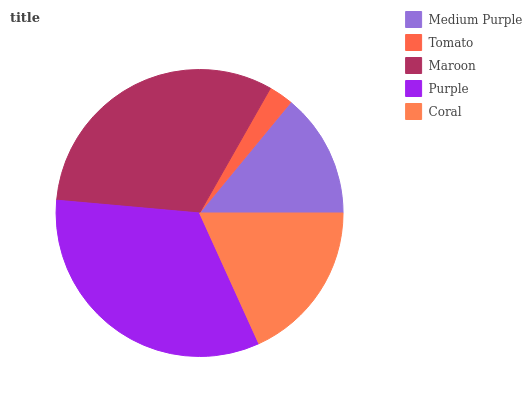Is Tomato the minimum?
Answer yes or no. Yes. Is Purple the maximum?
Answer yes or no. Yes. Is Maroon the minimum?
Answer yes or no. No. Is Maroon the maximum?
Answer yes or no. No. Is Maroon greater than Tomato?
Answer yes or no. Yes. Is Tomato less than Maroon?
Answer yes or no. Yes. Is Tomato greater than Maroon?
Answer yes or no. No. Is Maroon less than Tomato?
Answer yes or no. No. Is Coral the high median?
Answer yes or no. Yes. Is Coral the low median?
Answer yes or no. Yes. Is Maroon the high median?
Answer yes or no. No. Is Medium Purple the low median?
Answer yes or no. No. 